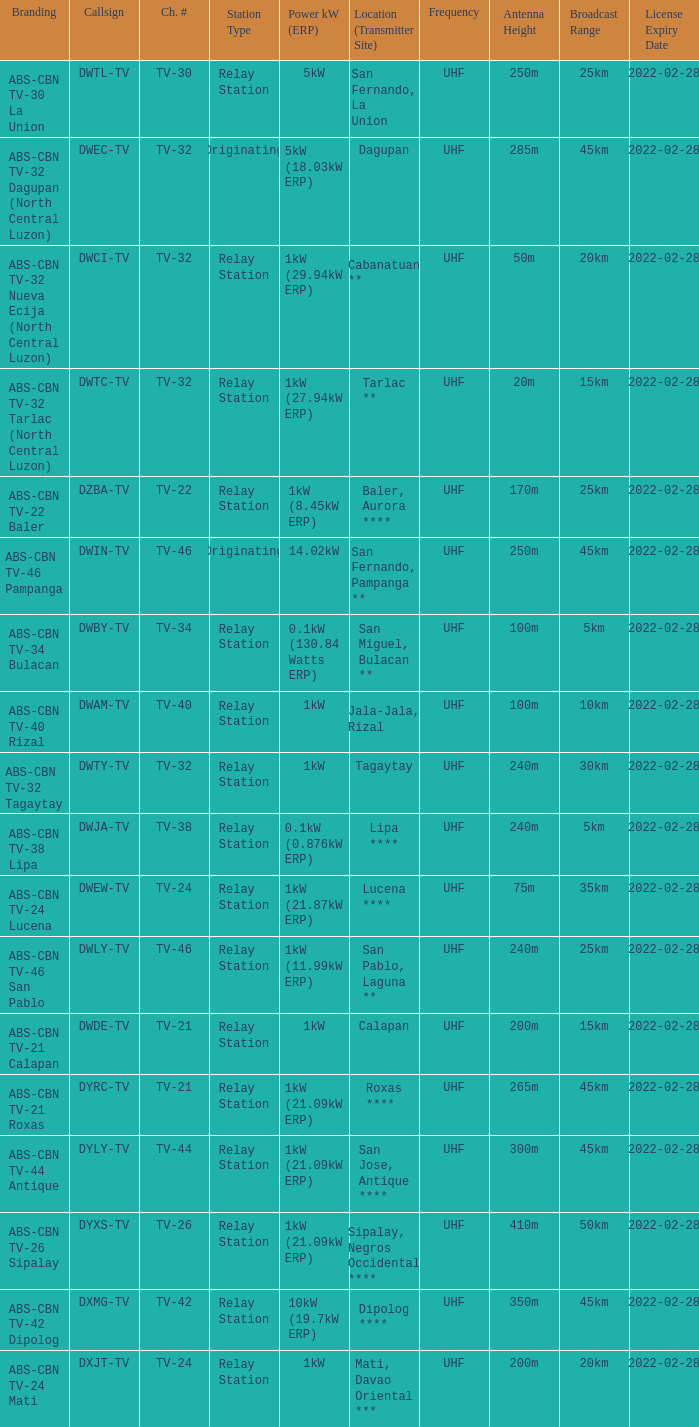What is the station type for the branding ABS-CBN TV-32 Tagaytay? Relay Station. 